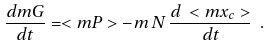<formula> <loc_0><loc_0><loc_500><loc_500>\frac { d { m G } } { d t } = < { m P } > - m \, N \, \frac { d \, < { m x } _ { c } > } { d t } \ .</formula> 